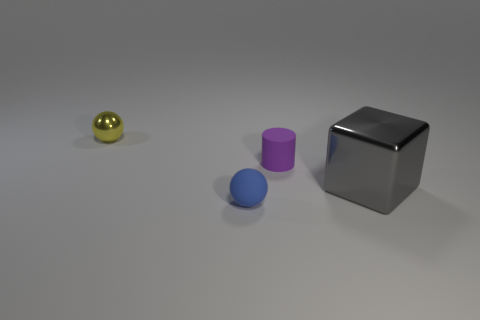What number of things are purple things or things in front of the small purple matte thing?
Your response must be concise. 3. Does the ball on the right side of the yellow shiny sphere have the same size as the matte thing that is to the right of the blue rubber ball?
Give a very brief answer. Yes. Are there any blue spheres made of the same material as the big gray thing?
Ensure brevity in your answer.  No. What is the shape of the small yellow object?
Your answer should be compact. Sphere. What is the shape of the rubber object behind the large gray metallic cube that is right of the yellow thing?
Provide a succinct answer. Cylinder. What number of other objects are there of the same shape as the purple rubber thing?
Provide a short and direct response. 0. What is the size of the ball that is in front of the tiny sphere to the left of the tiny blue rubber sphere?
Your answer should be compact. Small. Is there a blue sphere?
Give a very brief answer. Yes. What number of blocks are left of the rubber thing to the left of the tiny purple cylinder?
Ensure brevity in your answer.  0. There is a object to the right of the tiny cylinder; what shape is it?
Offer a terse response. Cube. 